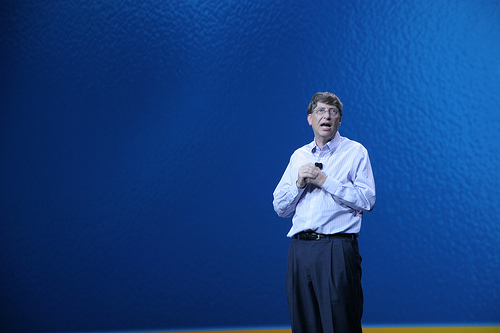<image>
Is the glasses in the head? No. The glasses is not contained within the head. These objects have a different spatial relationship. 